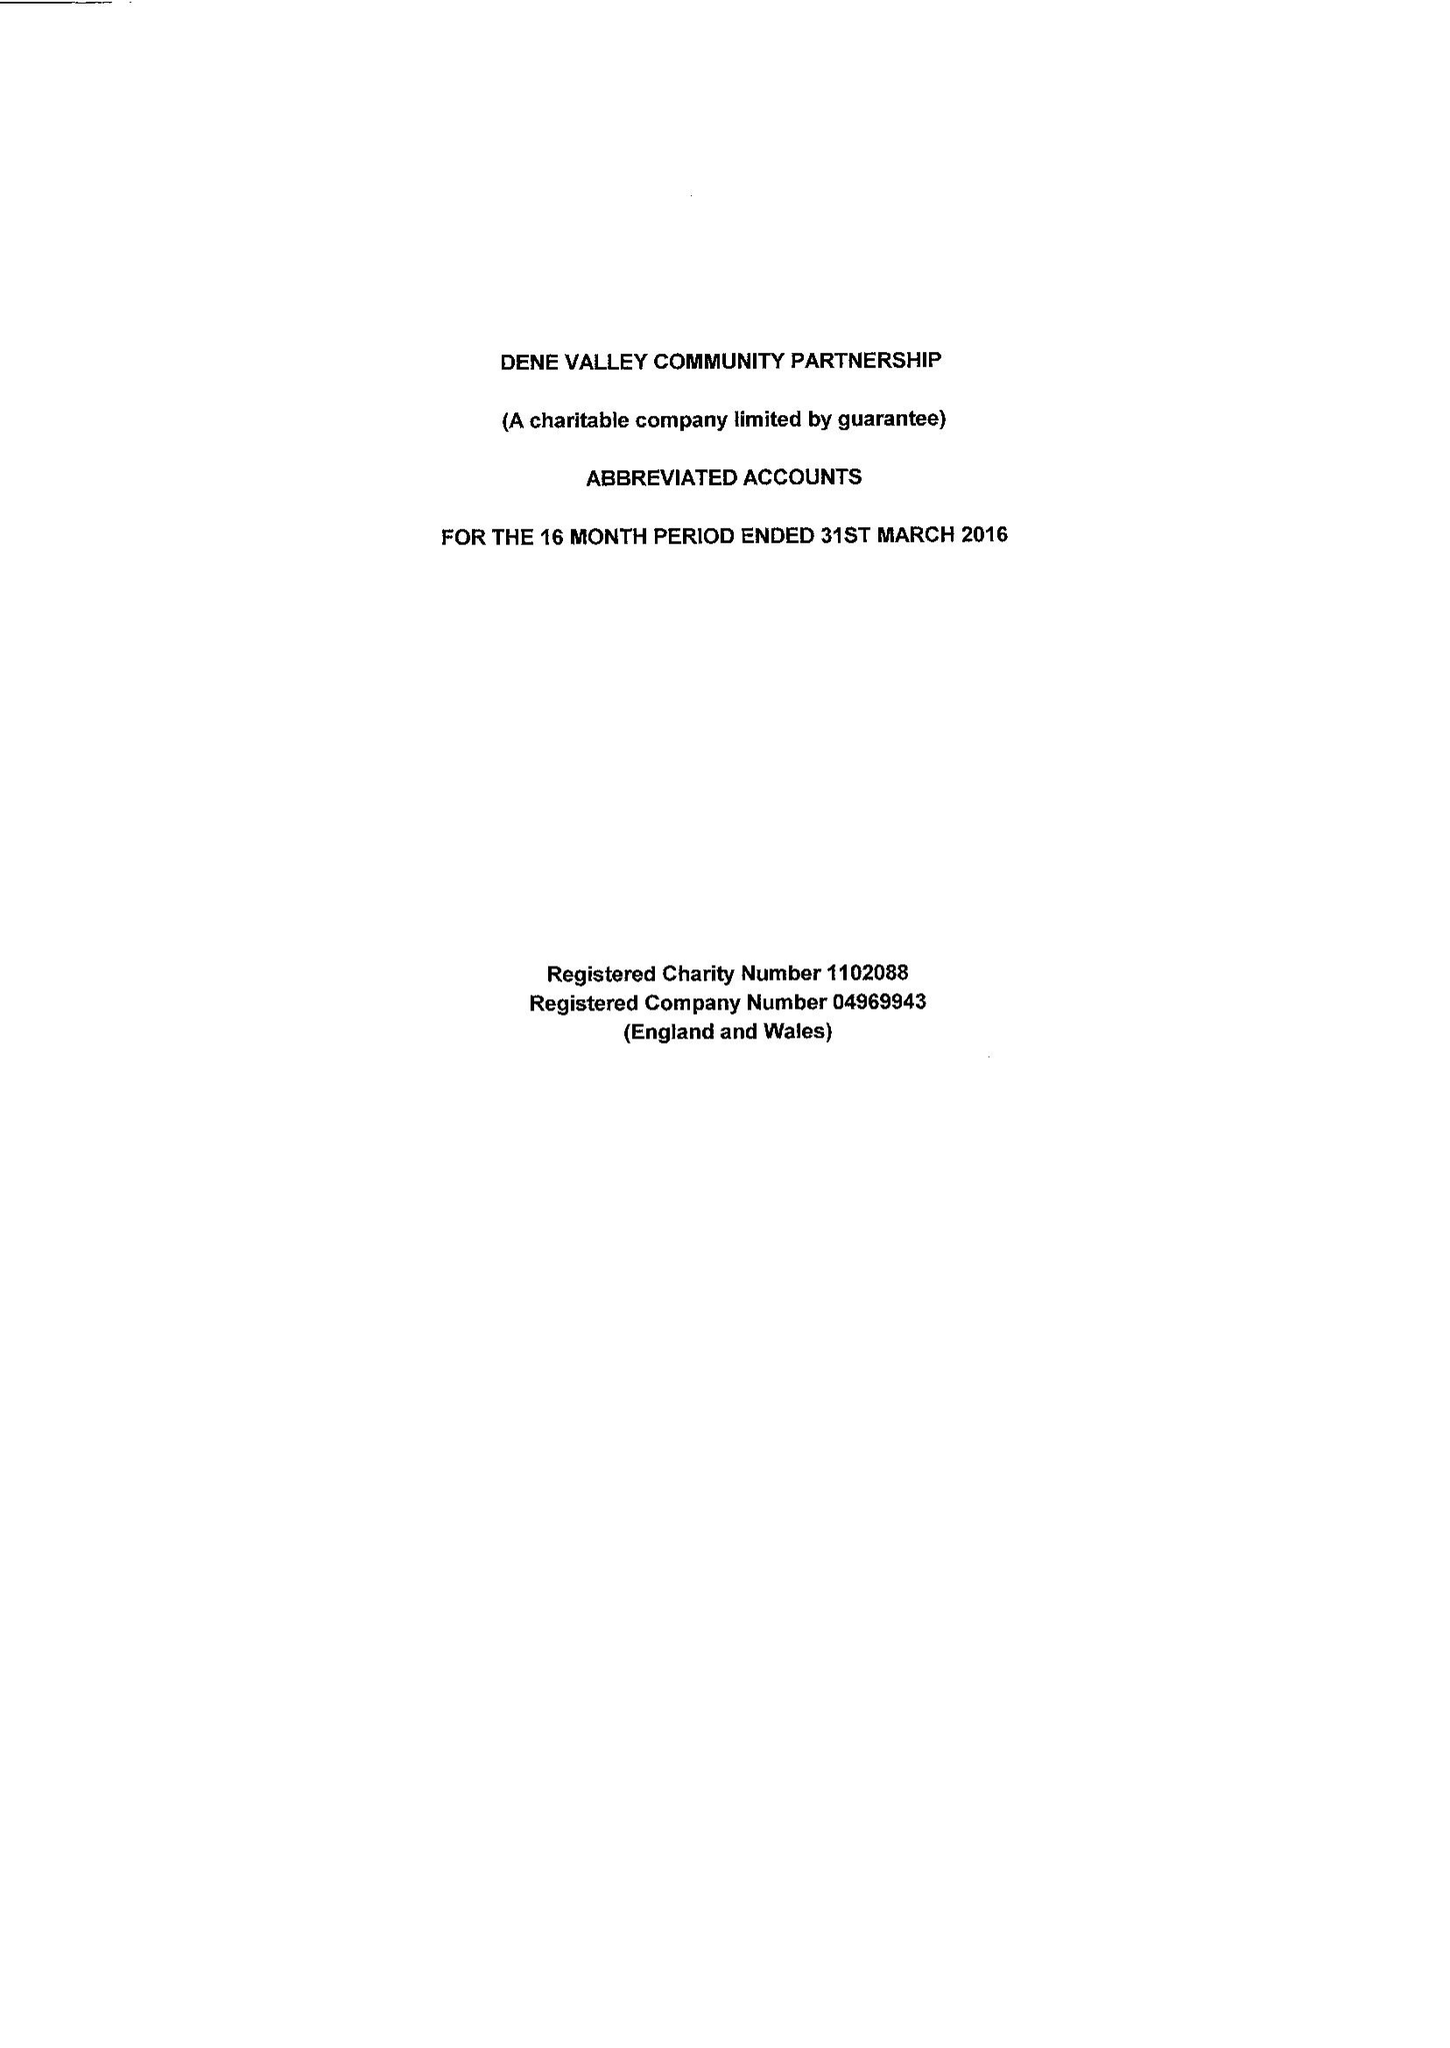What is the value for the address__postcode?
Answer the question using a single word or phrase. DL14 8TD 